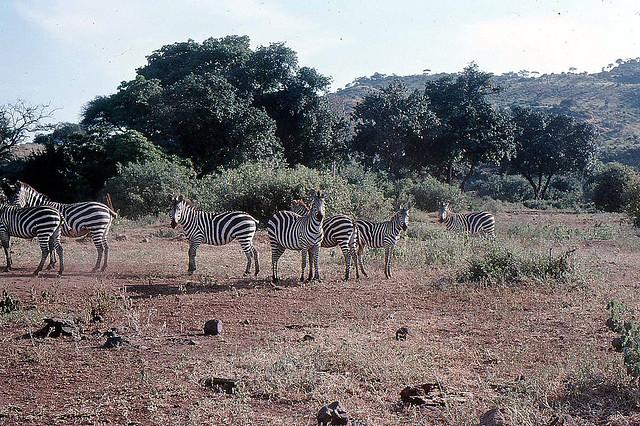Do the animals seem afraid of the photographer?
Answer briefly. No. Are these zebras in Africa?
Give a very brief answer. Yes. What are the zebras doing?
Be succinct. Standing. Are they all facing the same direction?
Be succinct. No. 